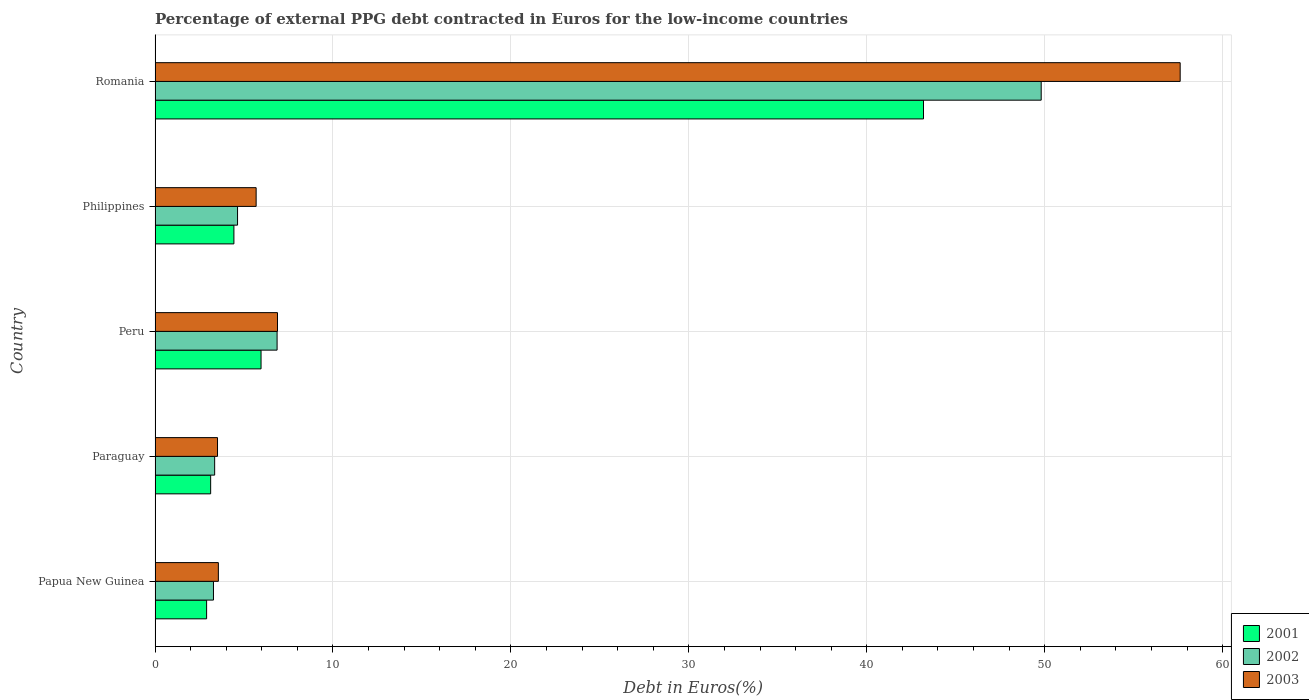How many different coloured bars are there?
Your response must be concise. 3. How many groups of bars are there?
Keep it short and to the point. 5. Are the number of bars per tick equal to the number of legend labels?
Provide a succinct answer. Yes. Are the number of bars on each tick of the Y-axis equal?
Your answer should be very brief. Yes. What is the label of the 5th group of bars from the top?
Give a very brief answer. Papua New Guinea. What is the percentage of external PPG debt contracted in Euros in 2003 in Romania?
Your answer should be compact. 57.61. Across all countries, what is the maximum percentage of external PPG debt contracted in Euros in 2003?
Offer a terse response. 57.61. Across all countries, what is the minimum percentage of external PPG debt contracted in Euros in 2002?
Offer a very short reply. 3.28. In which country was the percentage of external PPG debt contracted in Euros in 2003 maximum?
Ensure brevity in your answer.  Romania. In which country was the percentage of external PPG debt contracted in Euros in 2001 minimum?
Your answer should be very brief. Papua New Guinea. What is the total percentage of external PPG debt contracted in Euros in 2002 in the graph?
Make the answer very short. 67.93. What is the difference between the percentage of external PPG debt contracted in Euros in 2003 in Philippines and that in Romania?
Make the answer very short. -51.93. What is the difference between the percentage of external PPG debt contracted in Euros in 2001 in Papua New Guinea and the percentage of external PPG debt contracted in Euros in 2002 in Paraguay?
Ensure brevity in your answer.  -0.45. What is the average percentage of external PPG debt contracted in Euros in 2001 per country?
Give a very brief answer. 11.92. What is the difference between the percentage of external PPG debt contracted in Euros in 2002 and percentage of external PPG debt contracted in Euros in 2003 in Papua New Guinea?
Keep it short and to the point. -0.27. What is the ratio of the percentage of external PPG debt contracted in Euros in 2001 in Paraguay to that in Philippines?
Make the answer very short. 0.71. Is the difference between the percentage of external PPG debt contracted in Euros in 2002 in Paraguay and Romania greater than the difference between the percentage of external PPG debt contracted in Euros in 2003 in Paraguay and Romania?
Offer a very short reply. Yes. What is the difference between the highest and the second highest percentage of external PPG debt contracted in Euros in 2003?
Your response must be concise. 50.73. What is the difference between the highest and the lowest percentage of external PPG debt contracted in Euros in 2001?
Offer a terse response. 40.29. In how many countries, is the percentage of external PPG debt contracted in Euros in 2003 greater than the average percentage of external PPG debt contracted in Euros in 2003 taken over all countries?
Provide a succinct answer. 1. Is the sum of the percentage of external PPG debt contracted in Euros in 2001 in Papua New Guinea and Paraguay greater than the maximum percentage of external PPG debt contracted in Euros in 2002 across all countries?
Ensure brevity in your answer.  No. What does the 3rd bar from the bottom in Peru represents?
Offer a very short reply. 2003. Is it the case that in every country, the sum of the percentage of external PPG debt contracted in Euros in 2003 and percentage of external PPG debt contracted in Euros in 2002 is greater than the percentage of external PPG debt contracted in Euros in 2001?
Make the answer very short. Yes. Are all the bars in the graph horizontal?
Give a very brief answer. Yes. How many countries are there in the graph?
Offer a terse response. 5. Are the values on the major ticks of X-axis written in scientific E-notation?
Keep it short and to the point. No. How are the legend labels stacked?
Offer a terse response. Vertical. What is the title of the graph?
Ensure brevity in your answer.  Percentage of external PPG debt contracted in Euros for the low-income countries. What is the label or title of the X-axis?
Your response must be concise. Debt in Euros(%). What is the label or title of the Y-axis?
Offer a terse response. Country. What is the Debt in Euros(%) of 2001 in Papua New Guinea?
Keep it short and to the point. 2.9. What is the Debt in Euros(%) of 2002 in Papua New Guinea?
Make the answer very short. 3.28. What is the Debt in Euros(%) in 2003 in Papua New Guinea?
Give a very brief answer. 3.56. What is the Debt in Euros(%) of 2001 in Paraguay?
Provide a succinct answer. 3.12. What is the Debt in Euros(%) in 2002 in Paraguay?
Offer a very short reply. 3.35. What is the Debt in Euros(%) in 2003 in Paraguay?
Provide a short and direct response. 3.51. What is the Debt in Euros(%) of 2001 in Peru?
Keep it short and to the point. 5.96. What is the Debt in Euros(%) of 2002 in Peru?
Your answer should be very brief. 6.86. What is the Debt in Euros(%) in 2003 in Peru?
Provide a succinct answer. 6.88. What is the Debt in Euros(%) in 2001 in Philippines?
Keep it short and to the point. 4.43. What is the Debt in Euros(%) in 2002 in Philippines?
Keep it short and to the point. 4.64. What is the Debt in Euros(%) of 2003 in Philippines?
Provide a short and direct response. 5.68. What is the Debt in Euros(%) in 2001 in Romania?
Make the answer very short. 43.19. What is the Debt in Euros(%) of 2002 in Romania?
Offer a very short reply. 49.8. What is the Debt in Euros(%) in 2003 in Romania?
Your answer should be compact. 57.61. Across all countries, what is the maximum Debt in Euros(%) in 2001?
Ensure brevity in your answer.  43.19. Across all countries, what is the maximum Debt in Euros(%) in 2002?
Offer a terse response. 49.8. Across all countries, what is the maximum Debt in Euros(%) of 2003?
Keep it short and to the point. 57.61. Across all countries, what is the minimum Debt in Euros(%) in 2001?
Ensure brevity in your answer.  2.9. Across all countries, what is the minimum Debt in Euros(%) of 2002?
Provide a short and direct response. 3.28. Across all countries, what is the minimum Debt in Euros(%) of 2003?
Provide a succinct answer. 3.51. What is the total Debt in Euros(%) of 2001 in the graph?
Your answer should be very brief. 59.6. What is the total Debt in Euros(%) of 2002 in the graph?
Provide a short and direct response. 67.93. What is the total Debt in Euros(%) of 2003 in the graph?
Provide a short and direct response. 77.24. What is the difference between the Debt in Euros(%) in 2001 in Papua New Guinea and that in Paraguay?
Your response must be concise. -0.23. What is the difference between the Debt in Euros(%) in 2002 in Papua New Guinea and that in Paraguay?
Offer a terse response. -0.07. What is the difference between the Debt in Euros(%) in 2003 in Papua New Guinea and that in Paraguay?
Keep it short and to the point. 0.05. What is the difference between the Debt in Euros(%) of 2001 in Papua New Guinea and that in Peru?
Give a very brief answer. -3.06. What is the difference between the Debt in Euros(%) in 2002 in Papua New Guinea and that in Peru?
Provide a succinct answer. -3.58. What is the difference between the Debt in Euros(%) in 2003 in Papua New Guinea and that in Peru?
Your answer should be very brief. -3.32. What is the difference between the Debt in Euros(%) of 2001 in Papua New Guinea and that in Philippines?
Offer a very short reply. -1.53. What is the difference between the Debt in Euros(%) in 2002 in Papua New Guinea and that in Philippines?
Your response must be concise. -1.35. What is the difference between the Debt in Euros(%) in 2003 in Papua New Guinea and that in Philippines?
Give a very brief answer. -2.12. What is the difference between the Debt in Euros(%) in 2001 in Papua New Guinea and that in Romania?
Provide a succinct answer. -40.29. What is the difference between the Debt in Euros(%) in 2002 in Papua New Guinea and that in Romania?
Make the answer very short. -46.52. What is the difference between the Debt in Euros(%) of 2003 in Papua New Guinea and that in Romania?
Provide a succinct answer. -54.06. What is the difference between the Debt in Euros(%) of 2001 in Paraguay and that in Peru?
Provide a short and direct response. -2.83. What is the difference between the Debt in Euros(%) in 2002 in Paraguay and that in Peru?
Ensure brevity in your answer.  -3.51. What is the difference between the Debt in Euros(%) in 2003 in Paraguay and that in Peru?
Keep it short and to the point. -3.37. What is the difference between the Debt in Euros(%) in 2001 in Paraguay and that in Philippines?
Provide a short and direct response. -1.31. What is the difference between the Debt in Euros(%) of 2002 in Paraguay and that in Philippines?
Provide a short and direct response. -1.29. What is the difference between the Debt in Euros(%) of 2003 in Paraguay and that in Philippines?
Keep it short and to the point. -2.17. What is the difference between the Debt in Euros(%) in 2001 in Paraguay and that in Romania?
Your answer should be very brief. -40.06. What is the difference between the Debt in Euros(%) of 2002 in Paraguay and that in Romania?
Provide a succinct answer. -46.45. What is the difference between the Debt in Euros(%) in 2003 in Paraguay and that in Romania?
Provide a short and direct response. -54.1. What is the difference between the Debt in Euros(%) of 2001 in Peru and that in Philippines?
Your answer should be very brief. 1.53. What is the difference between the Debt in Euros(%) in 2002 in Peru and that in Philippines?
Your answer should be compact. 2.22. What is the difference between the Debt in Euros(%) of 2003 in Peru and that in Philippines?
Keep it short and to the point. 1.2. What is the difference between the Debt in Euros(%) in 2001 in Peru and that in Romania?
Offer a very short reply. -37.23. What is the difference between the Debt in Euros(%) in 2002 in Peru and that in Romania?
Your answer should be compact. -42.94. What is the difference between the Debt in Euros(%) of 2003 in Peru and that in Romania?
Make the answer very short. -50.73. What is the difference between the Debt in Euros(%) of 2001 in Philippines and that in Romania?
Offer a very short reply. -38.76. What is the difference between the Debt in Euros(%) in 2002 in Philippines and that in Romania?
Your answer should be very brief. -45.17. What is the difference between the Debt in Euros(%) in 2003 in Philippines and that in Romania?
Make the answer very short. -51.93. What is the difference between the Debt in Euros(%) of 2001 in Papua New Guinea and the Debt in Euros(%) of 2002 in Paraguay?
Your response must be concise. -0.45. What is the difference between the Debt in Euros(%) of 2001 in Papua New Guinea and the Debt in Euros(%) of 2003 in Paraguay?
Your answer should be compact. -0.61. What is the difference between the Debt in Euros(%) in 2002 in Papua New Guinea and the Debt in Euros(%) in 2003 in Paraguay?
Provide a short and direct response. -0.23. What is the difference between the Debt in Euros(%) of 2001 in Papua New Guinea and the Debt in Euros(%) of 2002 in Peru?
Keep it short and to the point. -3.96. What is the difference between the Debt in Euros(%) of 2001 in Papua New Guinea and the Debt in Euros(%) of 2003 in Peru?
Keep it short and to the point. -3.98. What is the difference between the Debt in Euros(%) of 2002 in Papua New Guinea and the Debt in Euros(%) of 2003 in Peru?
Offer a very short reply. -3.6. What is the difference between the Debt in Euros(%) of 2001 in Papua New Guinea and the Debt in Euros(%) of 2002 in Philippines?
Offer a terse response. -1.74. What is the difference between the Debt in Euros(%) in 2001 in Papua New Guinea and the Debt in Euros(%) in 2003 in Philippines?
Make the answer very short. -2.78. What is the difference between the Debt in Euros(%) of 2002 in Papua New Guinea and the Debt in Euros(%) of 2003 in Philippines?
Your response must be concise. -2.4. What is the difference between the Debt in Euros(%) of 2001 in Papua New Guinea and the Debt in Euros(%) of 2002 in Romania?
Offer a terse response. -46.91. What is the difference between the Debt in Euros(%) of 2001 in Papua New Guinea and the Debt in Euros(%) of 2003 in Romania?
Provide a short and direct response. -54.72. What is the difference between the Debt in Euros(%) in 2002 in Papua New Guinea and the Debt in Euros(%) in 2003 in Romania?
Your response must be concise. -54.33. What is the difference between the Debt in Euros(%) in 2001 in Paraguay and the Debt in Euros(%) in 2002 in Peru?
Provide a succinct answer. -3.73. What is the difference between the Debt in Euros(%) in 2001 in Paraguay and the Debt in Euros(%) in 2003 in Peru?
Offer a very short reply. -3.76. What is the difference between the Debt in Euros(%) in 2002 in Paraguay and the Debt in Euros(%) in 2003 in Peru?
Your answer should be very brief. -3.53. What is the difference between the Debt in Euros(%) in 2001 in Paraguay and the Debt in Euros(%) in 2002 in Philippines?
Ensure brevity in your answer.  -1.51. What is the difference between the Debt in Euros(%) in 2001 in Paraguay and the Debt in Euros(%) in 2003 in Philippines?
Ensure brevity in your answer.  -2.56. What is the difference between the Debt in Euros(%) in 2002 in Paraguay and the Debt in Euros(%) in 2003 in Philippines?
Provide a short and direct response. -2.33. What is the difference between the Debt in Euros(%) of 2001 in Paraguay and the Debt in Euros(%) of 2002 in Romania?
Provide a short and direct response. -46.68. What is the difference between the Debt in Euros(%) in 2001 in Paraguay and the Debt in Euros(%) in 2003 in Romania?
Ensure brevity in your answer.  -54.49. What is the difference between the Debt in Euros(%) in 2002 in Paraguay and the Debt in Euros(%) in 2003 in Romania?
Ensure brevity in your answer.  -54.26. What is the difference between the Debt in Euros(%) in 2001 in Peru and the Debt in Euros(%) in 2002 in Philippines?
Give a very brief answer. 1.32. What is the difference between the Debt in Euros(%) of 2001 in Peru and the Debt in Euros(%) of 2003 in Philippines?
Provide a short and direct response. 0.28. What is the difference between the Debt in Euros(%) of 2002 in Peru and the Debt in Euros(%) of 2003 in Philippines?
Provide a short and direct response. 1.18. What is the difference between the Debt in Euros(%) of 2001 in Peru and the Debt in Euros(%) of 2002 in Romania?
Your answer should be compact. -43.85. What is the difference between the Debt in Euros(%) of 2001 in Peru and the Debt in Euros(%) of 2003 in Romania?
Make the answer very short. -51.66. What is the difference between the Debt in Euros(%) of 2002 in Peru and the Debt in Euros(%) of 2003 in Romania?
Ensure brevity in your answer.  -50.76. What is the difference between the Debt in Euros(%) in 2001 in Philippines and the Debt in Euros(%) in 2002 in Romania?
Ensure brevity in your answer.  -45.37. What is the difference between the Debt in Euros(%) in 2001 in Philippines and the Debt in Euros(%) in 2003 in Romania?
Your response must be concise. -53.18. What is the difference between the Debt in Euros(%) in 2002 in Philippines and the Debt in Euros(%) in 2003 in Romania?
Make the answer very short. -52.98. What is the average Debt in Euros(%) of 2001 per country?
Your answer should be very brief. 11.92. What is the average Debt in Euros(%) of 2002 per country?
Ensure brevity in your answer.  13.59. What is the average Debt in Euros(%) in 2003 per country?
Give a very brief answer. 15.45. What is the difference between the Debt in Euros(%) in 2001 and Debt in Euros(%) in 2002 in Papua New Guinea?
Provide a short and direct response. -0.39. What is the difference between the Debt in Euros(%) of 2001 and Debt in Euros(%) of 2003 in Papua New Guinea?
Your answer should be very brief. -0.66. What is the difference between the Debt in Euros(%) in 2002 and Debt in Euros(%) in 2003 in Papua New Guinea?
Your answer should be compact. -0.27. What is the difference between the Debt in Euros(%) in 2001 and Debt in Euros(%) in 2002 in Paraguay?
Your answer should be very brief. -0.22. What is the difference between the Debt in Euros(%) in 2001 and Debt in Euros(%) in 2003 in Paraguay?
Provide a short and direct response. -0.39. What is the difference between the Debt in Euros(%) in 2002 and Debt in Euros(%) in 2003 in Paraguay?
Give a very brief answer. -0.16. What is the difference between the Debt in Euros(%) of 2001 and Debt in Euros(%) of 2002 in Peru?
Provide a short and direct response. -0.9. What is the difference between the Debt in Euros(%) in 2001 and Debt in Euros(%) in 2003 in Peru?
Ensure brevity in your answer.  -0.92. What is the difference between the Debt in Euros(%) of 2002 and Debt in Euros(%) of 2003 in Peru?
Your answer should be very brief. -0.02. What is the difference between the Debt in Euros(%) of 2001 and Debt in Euros(%) of 2002 in Philippines?
Provide a succinct answer. -0.21. What is the difference between the Debt in Euros(%) in 2001 and Debt in Euros(%) in 2003 in Philippines?
Provide a short and direct response. -1.25. What is the difference between the Debt in Euros(%) of 2002 and Debt in Euros(%) of 2003 in Philippines?
Give a very brief answer. -1.04. What is the difference between the Debt in Euros(%) in 2001 and Debt in Euros(%) in 2002 in Romania?
Provide a short and direct response. -6.61. What is the difference between the Debt in Euros(%) in 2001 and Debt in Euros(%) in 2003 in Romania?
Your response must be concise. -14.43. What is the difference between the Debt in Euros(%) in 2002 and Debt in Euros(%) in 2003 in Romania?
Keep it short and to the point. -7.81. What is the ratio of the Debt in Euros(%) in 2001 in Papua New Guinea to that in Paraguay?
Provide a short and direct response. 0.93. What is the ratio of the Debt in Euros(%) in 2002 in Papua New Guinea to that in Paraguay?
Provide a succinct answer. 0.98. What is the ratio of the Debt in Euros(%) of 2003 in Papua New Guinea to that in Paraguay?
Give a very brief answer. 1.01. What is the ratio of the Debt in Euros(%) of 2001 in Papua New Guinea to that in Peru?
Ensure brevity in your answer.  0.49. What is the ratio of the Debt in Euros(%) in 2002 in Papua New Guinea to that in Peru?
Offer a terse response. 0.48. What is the ratio of the Debt in Euros(%) in 2003 in Papua New Guinea to that in Peru?
Provide a short and direct response. 0.52. What is the ratio of the Debt in Euros(%) in 2001 in Papua New Guinea to that in Philippines?
Your answer should be compact. 0.65. What is the ratio of the Debt in Euros(%) of 2002 in Papua New Guinea to that in Philippines?
Offer a terse response. 0.71. What is the ratio of the Debt in Euros(%) in 2003 in Papua New Guinea to that in Philippines?
Ensure brevity in your answer.  0.63. What is the ratio of the Debt in Euros(%) in 2001 in Papua New Guinea to that in Romania?
Make the answer very short. 0.07. What is the ratio of the Debt in Euros(%) in 2002 in Papua New Guinea to that in Romania?
Provide a succinct answer. 0.07. What is the ratio of the Debt in Euros(%) of 2003 in Papua New Guinea to that in Romania?
Keep it short and to the point. 0.06. What is the ratio of the Debt in Euros(%) of 2001 in Paraguay to that in Peru?
Give a very brief answer. 0.52. What is the ratio of the Debt in Euros(%) of 2002 in Paraguay to that in Peru?
Your answer should be very brief. 0.49. What is the ratio of the Debt in Euros(%) of 2003 in Paraguay to that in Peru?
Your response must be concise. 0.51. What is the ratio of the Debt in Euros(%) of 2001 in Paraguay to that in Philippines?
Give a very brief answer. 0.71. What is the ratio of the Debt in Euros(%) of 2002 in Paraguay to that in Philippines?
Make the answer very short. 0.72. What is the ratio of the Debt in Euros(%) of 2003 in Paraguay to that in Philippines?
Give a very brief answer. 0.62. What is the ratio of the Debt in Euros(%) of 2001 in Paraguay to that in Romania?
Your answer should be very brief. 0.07. What is the ratio of the Debt in Euros(%) in 2002 in Paraguay to that in Romania?
Your answer should be compact. 0.07. What is the ratio of the Debt in Euros(%) in 2003 in Paraguay to that in Romania?
Provide a short and direct response. 0.06. What is the ratio of the Debt in Euros(%) of 2001 in Peru to that in Philippines?
Provide a succinct answer. 1.34. What is the ratio of the Debt in Euros(%) of 2002 in Peru to that in Philippines?
Offer a terse response. 1.48. What is the ratio of the Debt in Euros(%) of 2003 in Peru to that in Philippines?
Provide a short and direct response. 1.21. What is the ratio of the Debt in Euros(%) in 2001 in Peru to that in Romania?
Offer a very short reply. 0.14. What is the ratio of the Debt in Euros(%) of 2002 in Peru to that in Romania?
Offer a terse response. 0.14. What is the ratio of the Debt in Euros(%) of 2003 in Peru to that in Romania?
Make the answer very short. 0.12. What is the ratio of the Debt in Euros(%) of 2001 in Philippines to that in Romania?
Your answer should be compact. 0.1. What is the ratio of the Debt in Euros(%) in 2002 in Philippines to that in Romania?
Ensure brevity in your answer.  0.09. What is the ratio of the Debt in Euros(%) in 2003 in Philippines to that in Romania?
Offer a terse response. 0.1. What is the difference between the highest and the second highest Debt in Euros(%) of 2001?
Your response must be concise. 37.23. What is the difference between the highest and the second highest Debt in Euros(%) in 2002?
Your answer should be very brief. 42.94. What is the difference between the highest and the second highest Debt in Euros(%) in 2003?
Your response must be concise. 50.73. What is the difference between the highest and the lowest Debt in Euros(%) in 2001?
Provide a succinct answer. 40.29. What is the difference between the highest and the lowest Debt in Euros(%) of 2002?
Your response must be concise. 46.52. What is the difference between the highest and the lowest Debt in Euros(%) in 2003?
Keep it short and to the point. 54.1. 